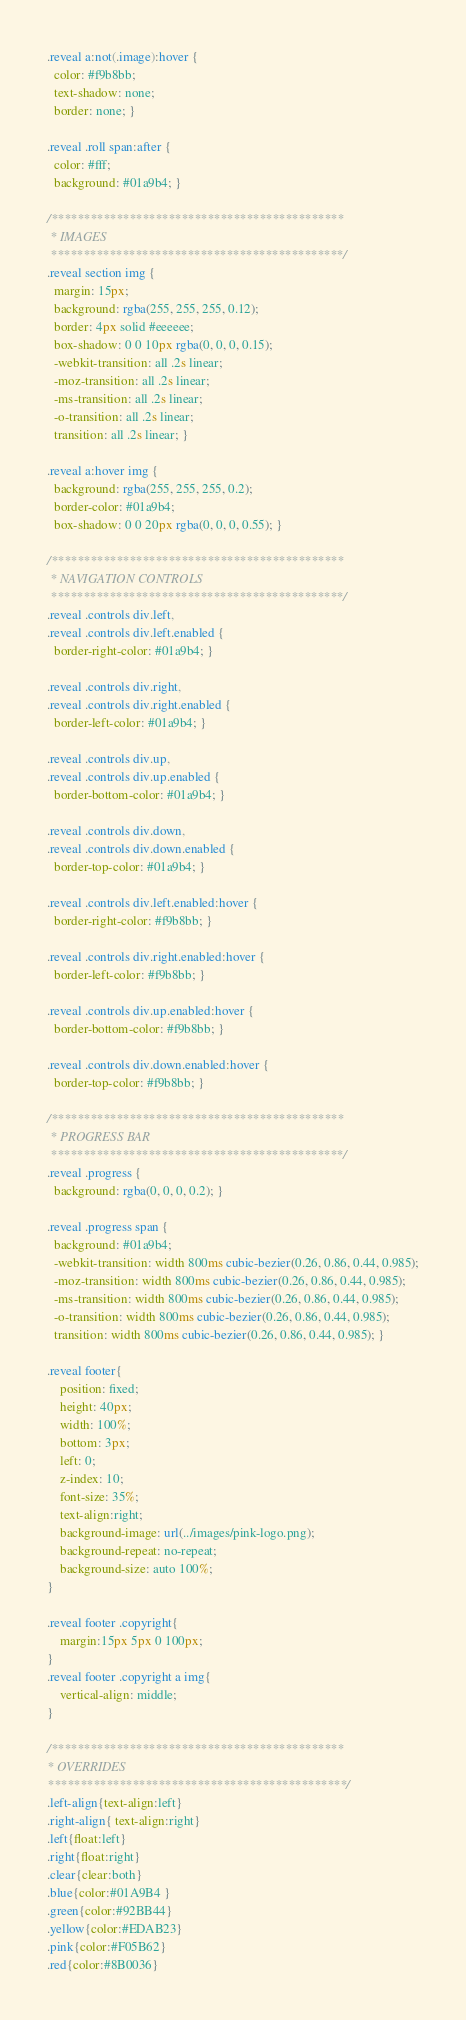Convert code to text. <code><loc_0><loc_0><loc_500><loc_500><_CSS_>.reveal a:not(.image):hover {
  color: #f9b8bb;
  text-shadow: none;
  border: none; }

.reveal .roll span:after {
  color: #fff;
  background: #01a9b4; }

/*********************************************
 * IMAGES
 *********************************************/
.reveal section img {
  margin: 15px;
  background: rgba(255, 255, 255, 0.12);
  border: 4px solid #eeeeee;
  box-shadow: 0 0 10px rgba(0, 0, 0, 0.15);
  -webkit-transition: all .2s linear;
  -moz-transition: all .2s linear;
  -ms-transition: all .2s linear;
  -o-transition: all .2s linear;
  transition: all .2s linear; }

.reveal a:hover img {
  background: rgba(255, 255, 255, 0.2);
  border-color: #01a9b4;
  box-shadow: 0 0 20px rgba(0, 0, 0, 0.55); }

/*********************************************
 * NAVIGATION CONTROLS
 *********************************************/
.reveal .controls div.left,
.reveal .controls div.left.enabled {
  border-right-color: #01a9b4; }

.reveal .controls div.right,
.reveal .controls div.right.enabled {
  border-left-color: #01a9b4; }

.reveal .controls div.up,
.reveal .controls div.up.enabled {
  border-bottom-color: #01a9b4; }

.reveal .controls div.down,
.reveal .controls div.down.enabled {
  border-top-color: #01a9b4; }

.reveal .controls div.left.enabled:hover {
  border-right-color: #f9b8bb; }

.reveal .controls div.right.enabled:hover {
  border-left-color: #f9b8bb; }

.reveal .controls div.up.enabled:hover {
  border-bottom-color: #f9b8bb; }

.reveal .controls div.down.enabled:hover {
  border-top-color: #f9b8bb; }

/*********************************************
 * PROGRESS BAR
 *********************************************/
.reveal .progress {
  background: rgba(0, 0, 0, 0.2); }

.reveal .progress span {
  background: #01a9b4;
  -webkit-transition: width 800ms cubic-bezier(0.26, 0.86, 0.44, 0.985);
  -moz-transition: width 800ms cubic-bezier(0.26, 0.86, 0.44, 0.985);
  -ms-transition: width 800ms cubic-bezier(0.26, 0.86, 0.44, 0.985);
  -o-transition: width 800ms cubic-bezier(0.26, 0.86, 0.44, 0.985);
  transition: width 800ms cubic-bezier(0.26, 0.86, 0.44, 0.985); }

.reveal footer{
    position: fixed;
    height: 40px;
    width: 100%;
    bottom: 3px;
    left: 0;
    z-index: 10;
    font-size: 35%;
    text-align:right;
    background-image: url(../images/pink-logo.png);
    background-repeat: no-repeat;
    background-size: auto 100%;
}

.reveal footer .copyright{
    margin:15px 5px 0 100px;
}
.reveal footer .copyright a img{
    vertical-align: middle;
}

/*********************************************
* OVERRIDES
**********************************************/
.left-align{text-align:left}
.right-align{ text-align:right}
.left{float:left}
.right{float:right}
.clear{clear:both}
.blue{color:#01A9B4 }
.green{color:#92BB44}
.yellow{color:#EDAB23}
.pink{color:#F05B62}
.red{color:#8B0036}</code> 